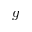Convert formula to latex. <formula><loc_0><loc_0><loc_500><loc_500>g</formula> 